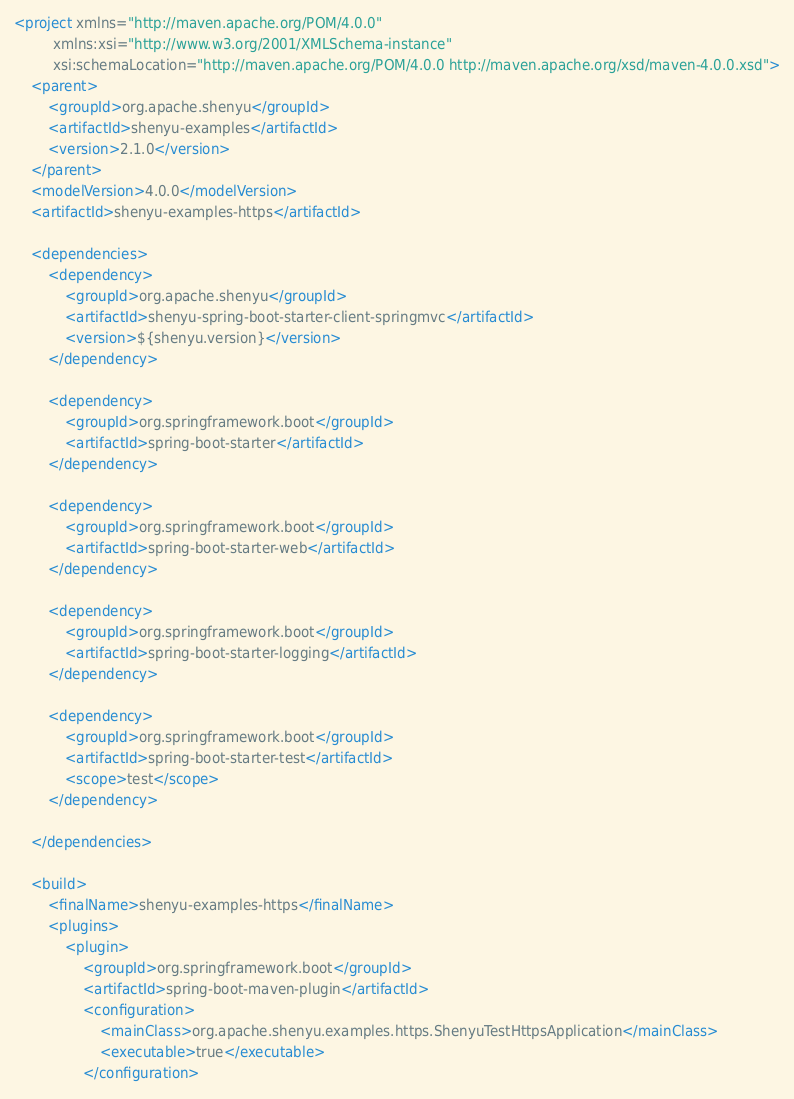<code> <loc_0><loc_0><loc_500><loc_500><_XML_><project xmlns="http://maven.apache.org/POM/4.0.0"
         xmlns:xsi="http://www.w3.org/2001/XMLSchema-instance"
         xsi:schemaLocation="http://maven.apache.org/POM/4.0.0 http://maven.apache.org/xsd/maven-4.0.0.xsd">
    <parent>
        <groupId>org.apache.shenyu</groupId>
        <artifactId>shenyu-examples</artifactId>
        <version>2.1.0</version>
    </parent>
    <modelVersion>4.0.0</modelVersion>
    <artifactId>shenyu-examples-https</artifactId>

    <dependencies>
        <dependency>
            <groupId>org.apache.shenyu</groupId>
            <artifactId>shenyu-spring-boot-starter-client-springmvc</artifactId>
            <version>${shenyu.version}</version>
        </dependency>

        <dependency>
            <groupId>org.springframework.boot</groupId>
            <artifactId>spring-boot-starter</artifactId>
        </dependency>

        <dependency>
            <groupId>org.springframework.boot</groupId>
            <artifactId>spring-boot-starter-web</artifactId>
        </dependency>

        <dependency>
            <groupId>org.springframework.boot</groupId>
            <artifactId>spring-boot-starter-logging</artifactId>
        </dependency>

        <dependency>
            <groupId>org.springframework.boot</groupId>
            <artifactId>spring-boot-starter-test</artifactId>
            <scope>test</scope>
        </dependency>

    </dependencies>

    <build>
        <finalName>shenyu-examples-https</finalName>
        <plugins>
            <plugin>
                <groupId>org.springframework.boot</groupId>
                <artifactId>spring-boot-maven-plugin</artifactId>
                <configuration>
                    <mainClass>org.apache.shenyu.examples.https.ShenyuTestHttpsApplication</mainClass>
                    <executable>true</executable>
                </configuration></code> 